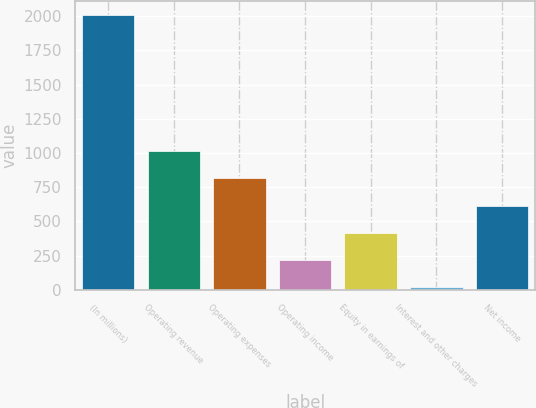Convert chart to OTSL. <chart><loc_0><loc_0><loc_500><loc_500><bar_chart><fcel>(In millions)<fcel>Operating revenue<fcel>Operating expenses<fcel>Operating income<fcel>Equity in earnings of<fcel>Interest and other charges<fcel>Net income<nl><fcel>2007<fcel>1013.5<fcel>814.8<fcel>218.7<fcel>417.4<fcel>20<fcel>616.1<nl></chart> 